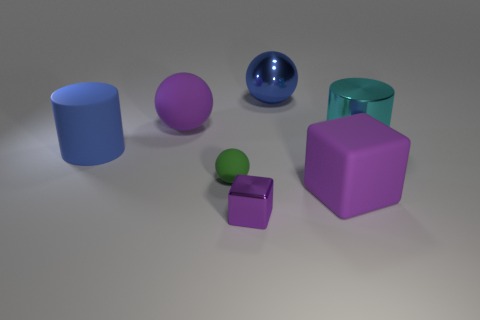Subtract all big blue balls. How many balls are left? 2 Subtract all blue spheres. How many spheres are left? 2 Add 2 large objects. How many objects exist? 9 Subtract all balls. How many objects are left? 4 Subtract 1 blocks. How many blocks are left? 1 Add 1 purple spheres. How many purple spheres exist? 2 Subtract 0 brown cylinders. How many objects are left? 7 Subtract all gray balls. Subtract all purple cylinders. How many balls are left? 3 Subtract all red matte cubes. Subtract all blue rubber cylinders. How many objects are left? 6 Add 2 tiny green matte objects. How many tiny green matte objects are left? 3 